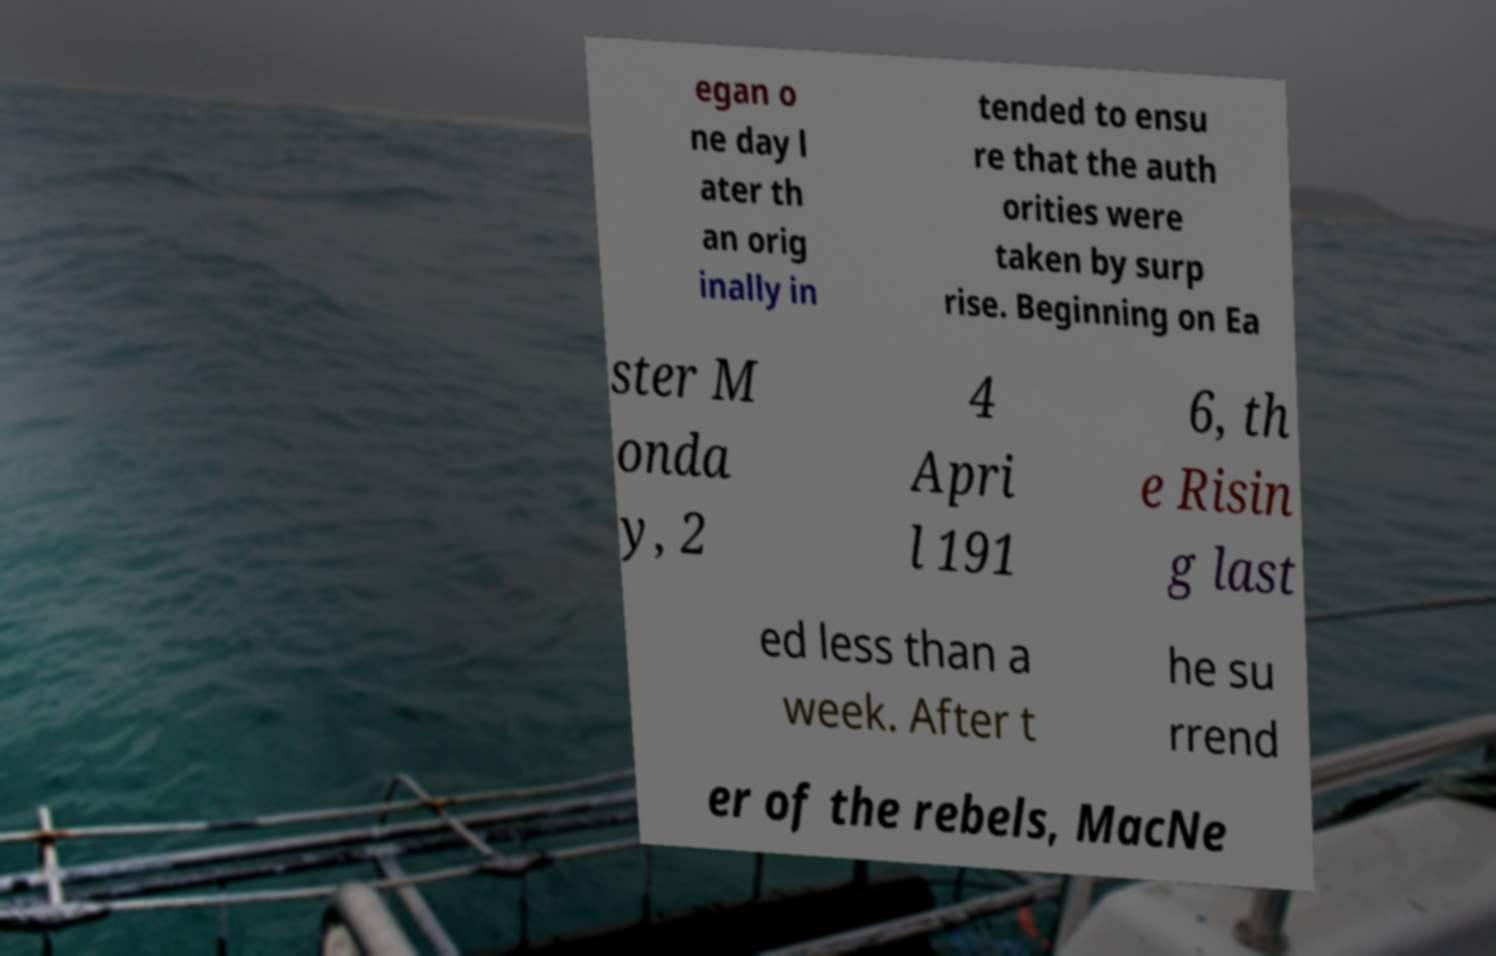Can you accurately transcribe the text from the provided image for me? egan o ne day l ater th an orig inally in tended to ensu re that the auth orities were taken by surp rise. Beginning on Ea ster M onda y, 2 4 Apri l 191 6, th e Risin g last ed less than a week. After t he su rrend er of the rebels, MacNe 